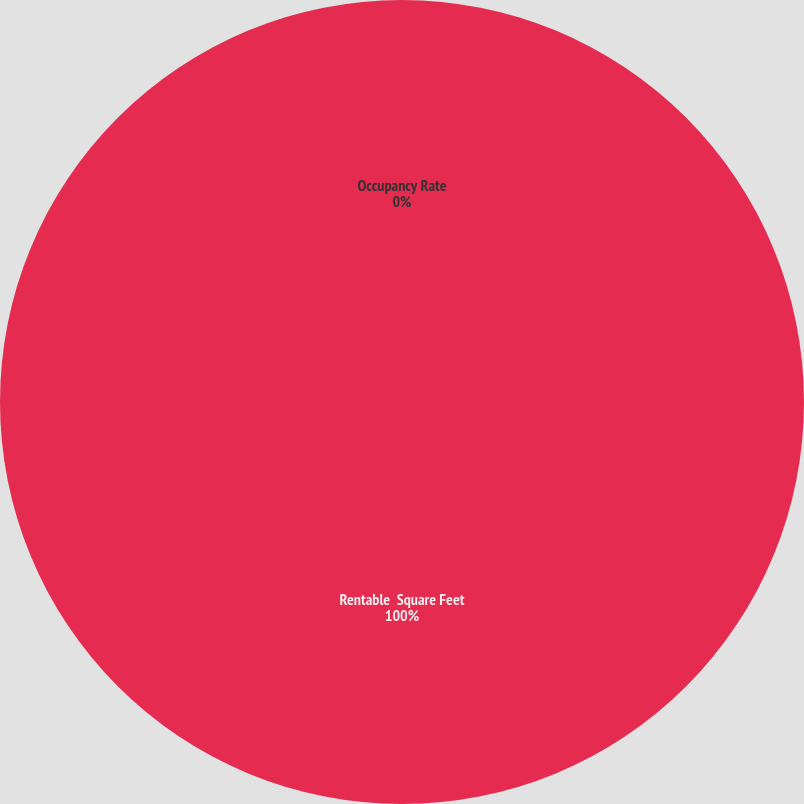<chart> <loc_0><loc_0><loc_500><loc_500><pie_chart><fcel>Rentable  Square Feet<fcel>Occupancy Rate<fcel>Average Annual  Escalated Rent  Per Square Foot<nl><fcel>100.0%<fcel>0.0%<fcel>0.0%<nl></chart> 